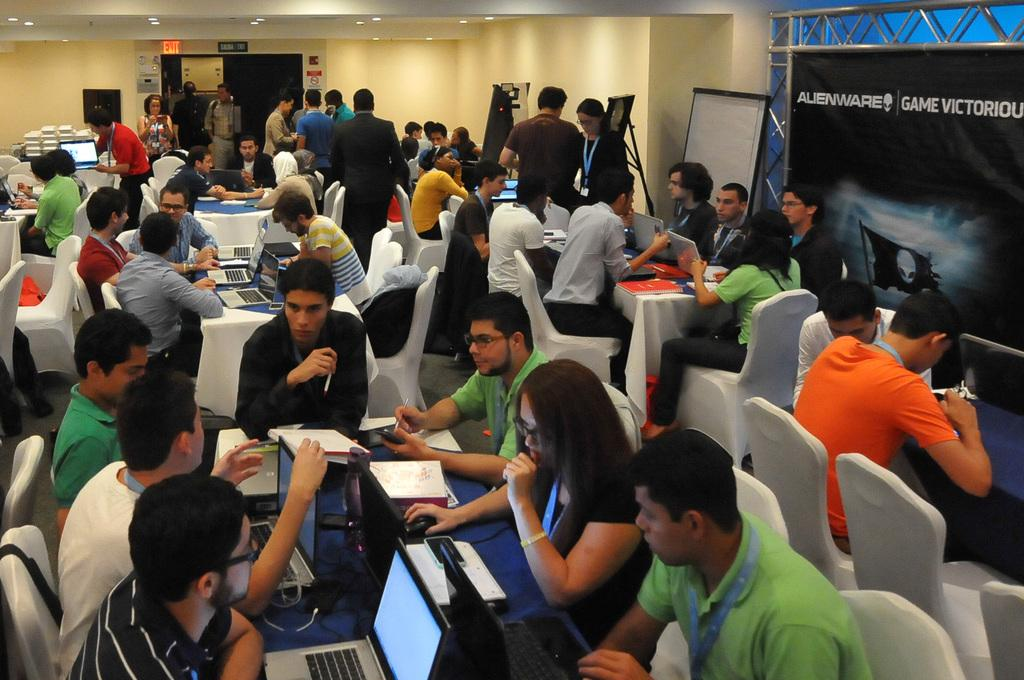What are the people in the image doing? The people in the image are sitting in chairs and using laptops. Where are the laptops placed? The laptops are placed on a table. What can be seen on the right side of the image? There is a banner on the right side of the image. How many tickets are visible in the image? There are no tickets present in the image. What type of paper is being used by the people in the image? The people in the image are using laptops, not paper. 